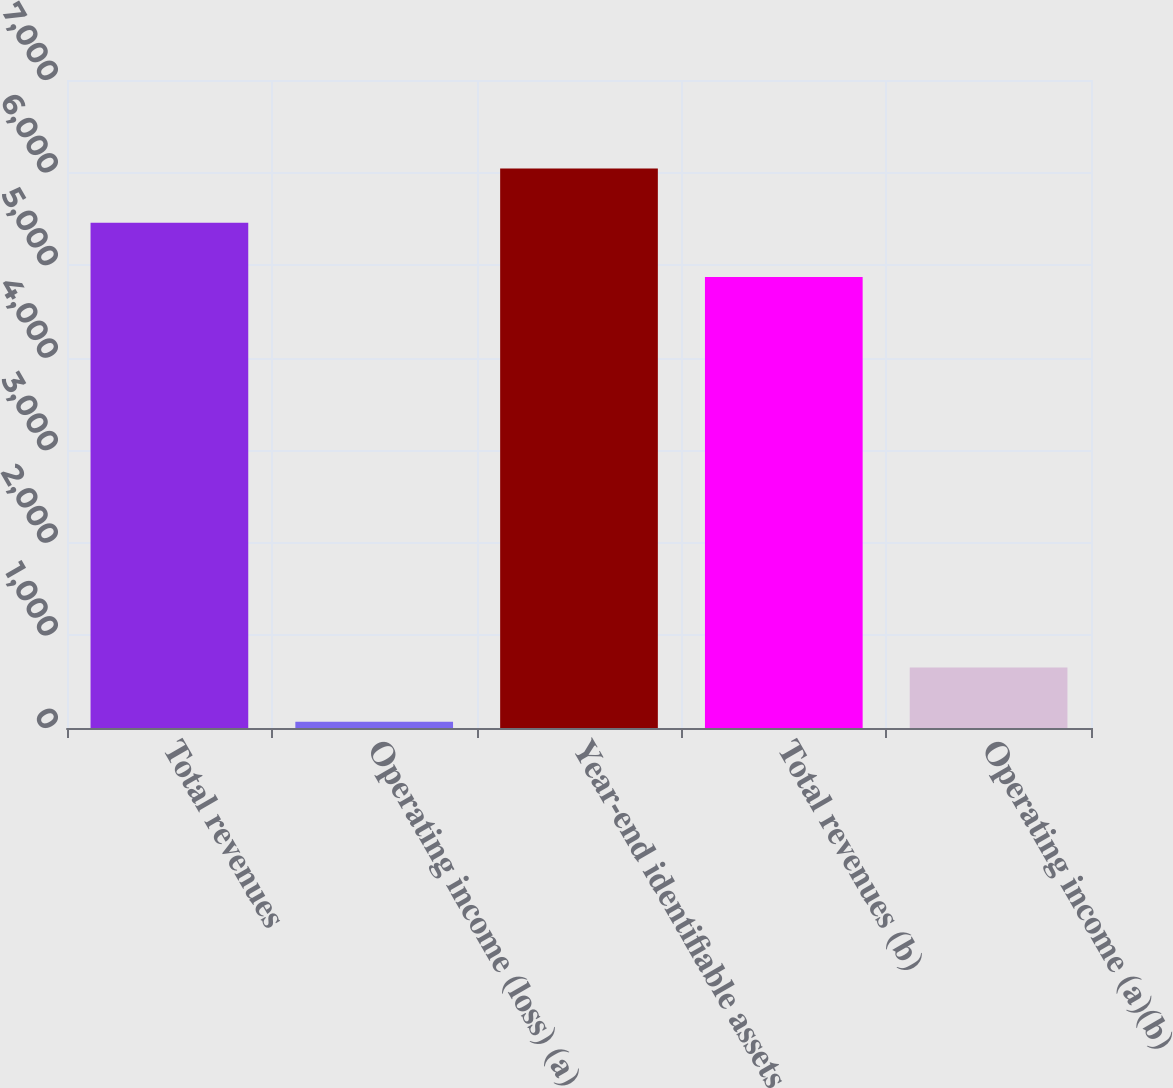Convert chart. <chart><loc_0><loc_0><loc_500><loc_500><bar_chart><fcel>Total revenues<fcel>Operating income (loss) (a)<fcel>Year-end identifiable assets<fcel>Total revenues (b)<fcel>Operating income (a)(b)<nl><fcel>5457.3<fcel>67<fcel>6043.6<fcel>4871<fcel>653.3<nl></chart> 